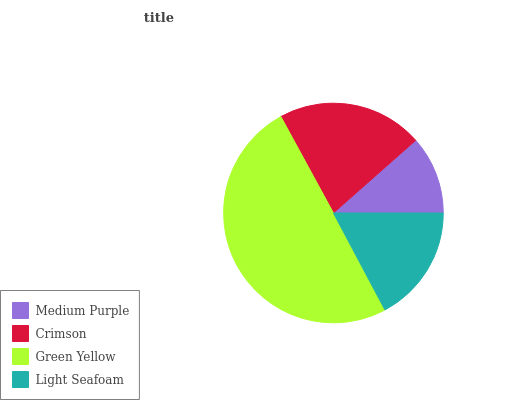Is Medium Purple the minimum?
Answer yes or no. Yes. Is Green Yellow the maximum?
Answer yes or no. Yes. Is Crimson the minimum?
Answer yes or no. No. Is Crimson the maximum?
Answer yes or no. No. Is Crimson greater than Medium Purple?
Answer yes or no. Yes. Is Medium Purple less than Crimson?
Answer yes or no. Yes. Is Medium Purple greater than Crimson?
Answer yes or no. No. Is Crimson less than Medium Purple?
Answer yes or no. No. Is Crimson the high median?
Answer yes or no. Yes. Is Light Seafoam the low median?
Answer yes or no. Yes. Is Green Yellow the high median?
Answer yes or no. No. Is Medium Purple the low median?
Answer yes or no. No. 